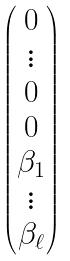Convert formula to latex. <formula><loc_0><loc_0><loc_500><loc_500>\begin{pmatrix} 0 \\ \vdots \\ 0 \\ 0 \\ \beta _ { 1 } \\ \vdots \\ \beta _ { \ell } \end{pmatrix}</formula> 